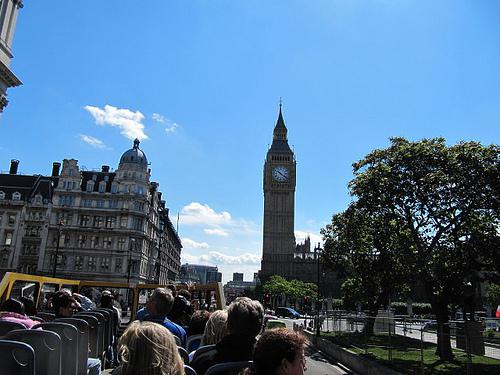Question: how many signal lights are visible?
Choices:
A. 3.
B. 2.
C. 1.
D. 0.
Answer with the letter. Answer: B 